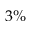Convert formula to latex. <formula><loc_0><loc_0><loc_500><loc_500>3 \%</formula> 